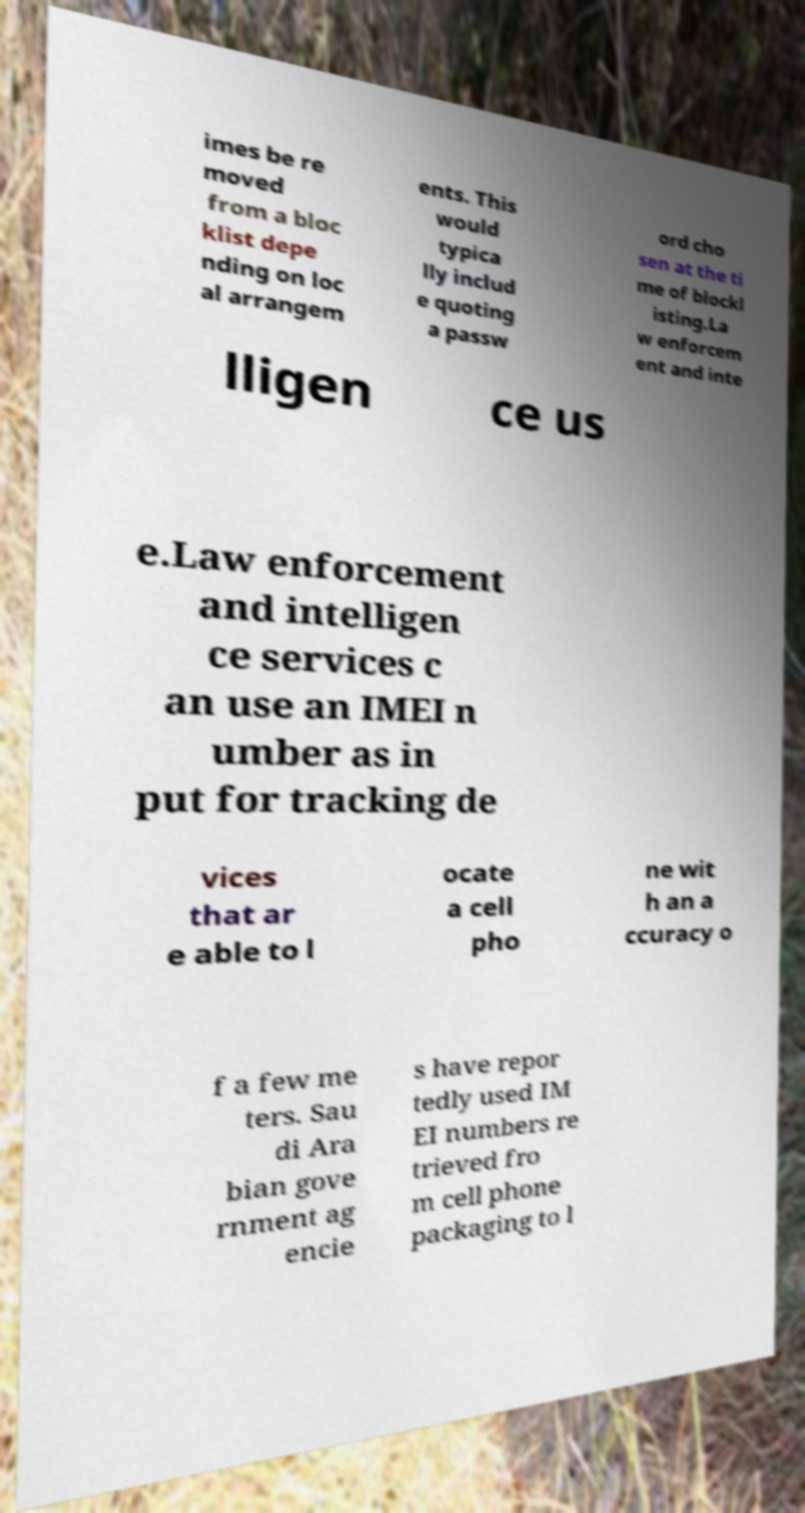Please read and relay the text visible in this image. What does it say? imes be re moved from a bloc klist depe nding on loc al arrangem ents. This would typica lly includ e quoting a passw ord cho sen at the ti me of blockl isting.La w enforcem ent and inte lligen ce us e.Law enforcement and intelligen ce services c an use an IMEI n umber as in put for tracking de vices that ar e able to l ocate a cell pho ne wit h an a ccuracy o f a few me ters. Sau di Ara bian gove rnment ag encie s have repor tedly used IM EI numbers re trieved fro m cell phone packaging to l 